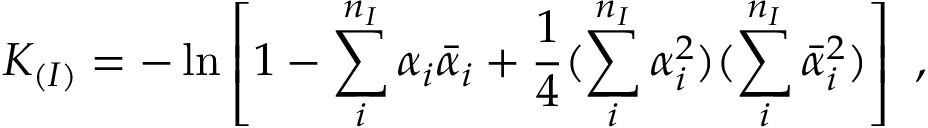<formula> <loc_0><loc_0><loc_500><loc_500>K _ { ( I ) } = - \ln \left [ 1 - \sum _ { i } ^ { n _ { I } } \alpha _ { i } { \bar { \alpha } } _ { i } + { \frac { 1 } { 4 } } ( \sum _ { i } ^ { n _ { I } } \alpha _ { i } ^ { 2 } ) ( \sum _ { i } ^ { n _ { I } } { \bar { \alpha } } _ { i } ^ { 2 } ) \right ] \ ,</formula> 